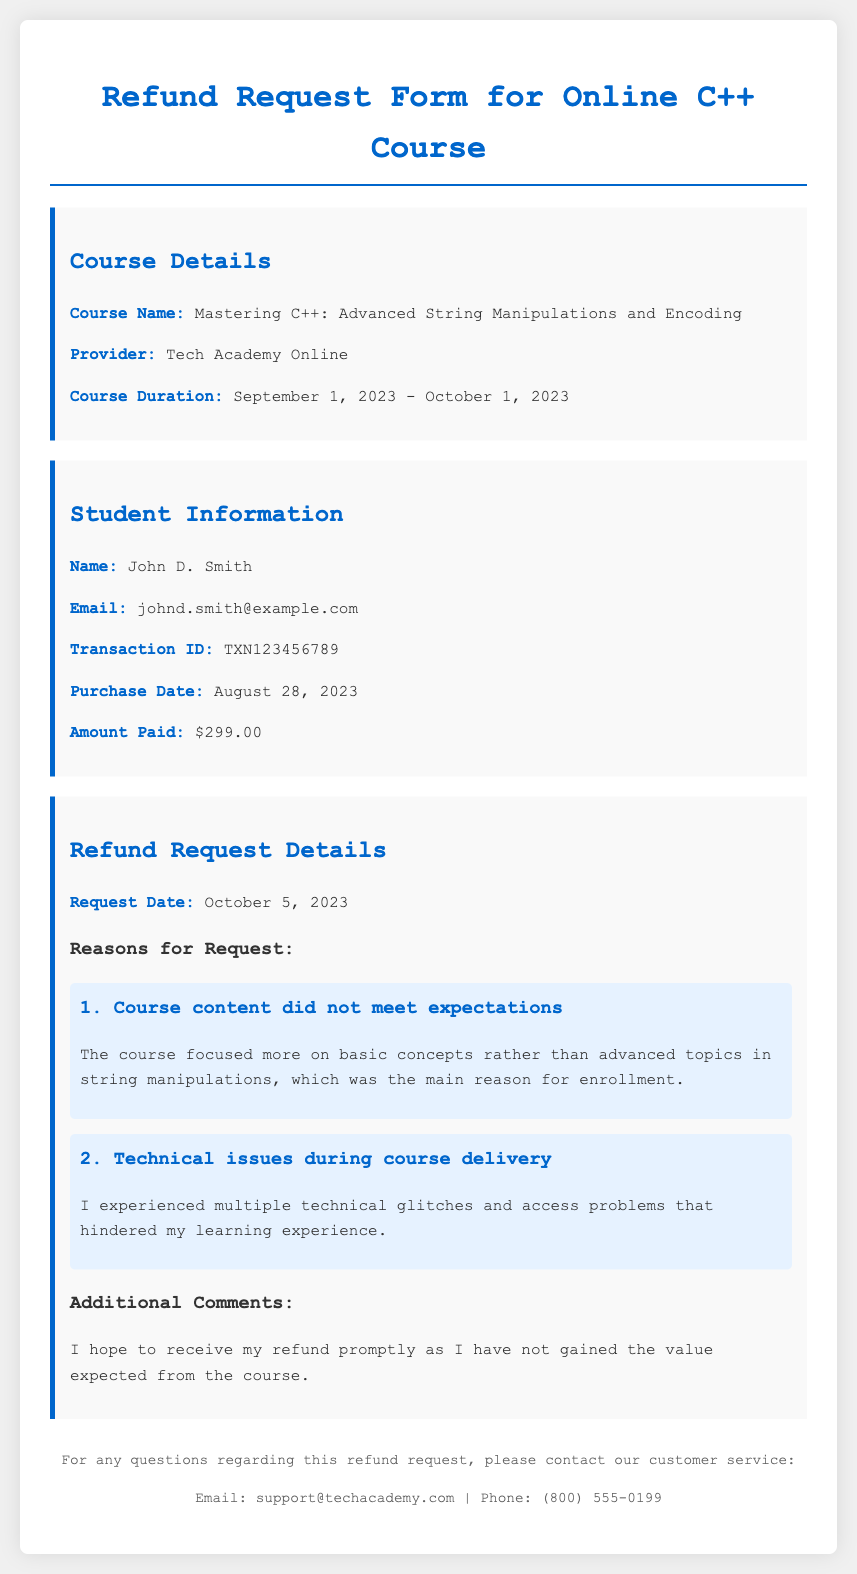What is the course name? The course name is explicitly stated in the Course Details section of the document.
Answer: Mastering C++: Advanced String Manipulations and Encoding Who is the course provider? The provider of the course is mentioned in the Course Details section.
Answer: Tech Academy Online What is the transaction ID? The transaction ID is provided in the Student Information section.
Answer: TXN123456789 What was the amount paid for the course? The amount paid is listed in the Student Information section of the document.
Answer: $299.00 When was the refund request submitted? The request date is mentioned in the Refund Request Details section.
Answer: October 5, 2023 What was the main reason for the refund request? This requires inference from the reasons presented in the Refund Request Details.
Answer: Course content did not meet expectations How many technical issues were reported during the course? The document mentions one significant issue related to technical glitches.
Answer: Multiple What is the expected resolution mentioned in the additional comments? The additional comments section indicates the student's expectation regarding the refund.
Answer: Refund promptly What is the period of the course? The course duration is explicitly provided in the Course Details section.
Answer: September 1, 2023 - October 1, 2023 